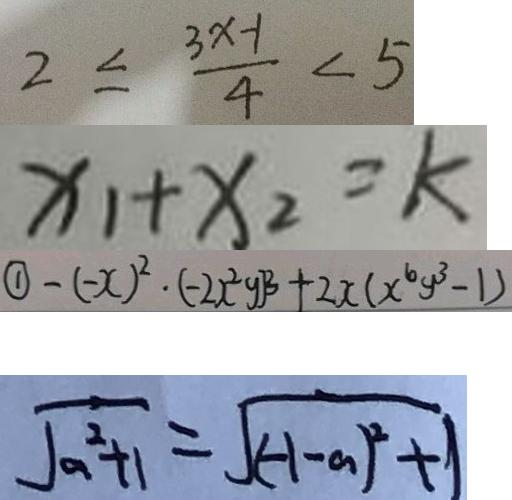Convert formula to latex. <formula><loc_0><loc_0><loc_500><loc_500>2 \leq \frac { 3 x - 1 } { 4 } < 5 
 x _ { 1 } + x _ { 2 } = k 
 \textcircled { 1 } - ( - x ) ^ { 2 } \cdot ( - 2 x ^ { 2 } y ) ^ { 3 } + 2 x ( x ^ { 6 } y ^ { 3 } - 1 ) 
 \sqrt { a ^ { 2 } + 1 } = \sqrt { ( - 1 - a ) ^ { 2 } + 1 }</formula> 